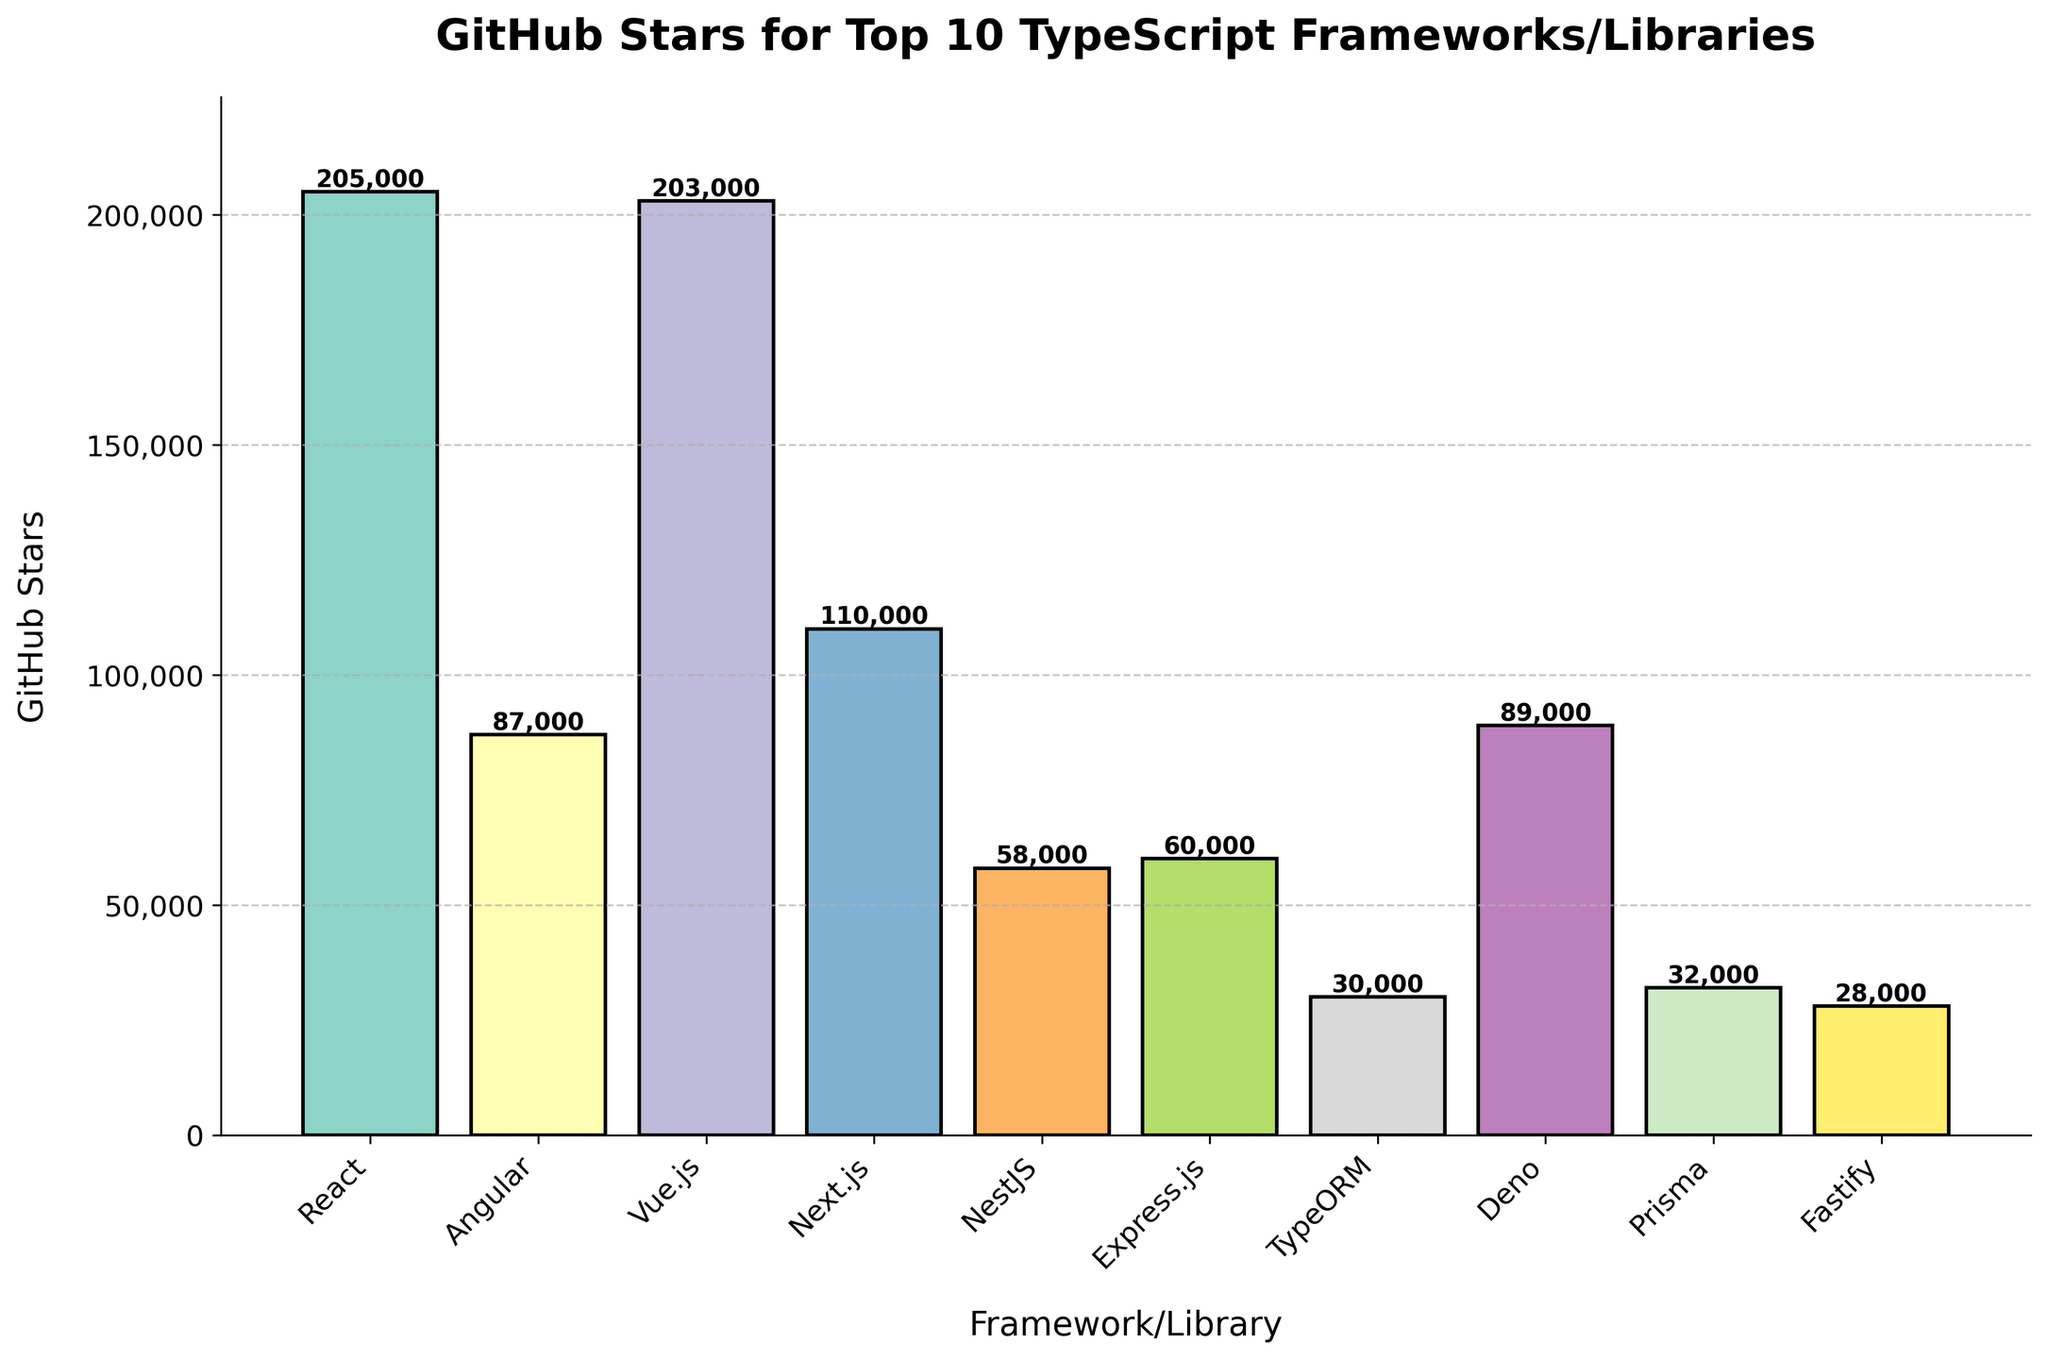Which TypeScript framework/library has the highest number of GitHub stars? Look for the tallest bar on the chart. The bar for React is the tallest, indicating it has the highest number of GitHub stars.
Answer: React What is the difference in GitHub stars between React and Vue.js? Identify the bar heights for React and Vue.js. React has 205,000 stars, and Vue.js has 203,000 stars. Calculate the difference: 205,000 - 203,000.
Answer: 2,000 Which framework/library has more GitHub stars: Angular or Deno? Compare the heights of the bars for Angular and Deno. Angular has 87,000 stars, and Deno has 89,000 stars.
Answer: Deno What is the sum of GitHub stars for NestJS, Express.js, and TypeORM? Find the star counts for NestJS (58,000), Express.js (60,000), and TypeORM (30,000). Sum them up: 58,000 + 60,000 + 30,000.
Answer: 148,000 Is the number of GitHub stars for Prisma closer to the number for Fastify or TypeORM? Compare the height of the Prisma bar (32,000) to those of Fastify (28,000) and TypeORM (30,000). The difference with Fastify is 4,000 and with TypeORM is 2,000.
Answer: TypeORM What is the average number of GitHub stars for Angular, Next.js, and Vue.js? Sum the star counts: Angular (87,000), Next.js (110,000), and Vue.js (203,000). Calculate: (87,000 + 110,000 + 203,000) / 3.
Answer: 133,333 Which framework/library has the least number of GitHub stars? Look for the shortest bar on the chart. The bar for Fastify is the shortest, indicating it has the least number of GitHub stars.
Answer: Fastify By how much do the GitHub stars for Next.js exceed those for Express.js? Identify the bar heights for Next.js (110,000) and Express.js (60,000). Calculate the difference: 110,000 - 60,000.
Answer: 50,000 Which color represents NestJS in the bar chart? Observe the colors assigned to each bar and identify the one corresponding to NestJS.
Answer: Variable answer based on visual inspection How much do the total GitHub stars for the frameworks/libraries with more than 100,000 stars add up to? Identify and sum the star counts for React (205,000), Vue.js (203,000), and Next.js (110,000). Calculate: 205,000 + 203,000 + 110,000.
Answer: 518,000 